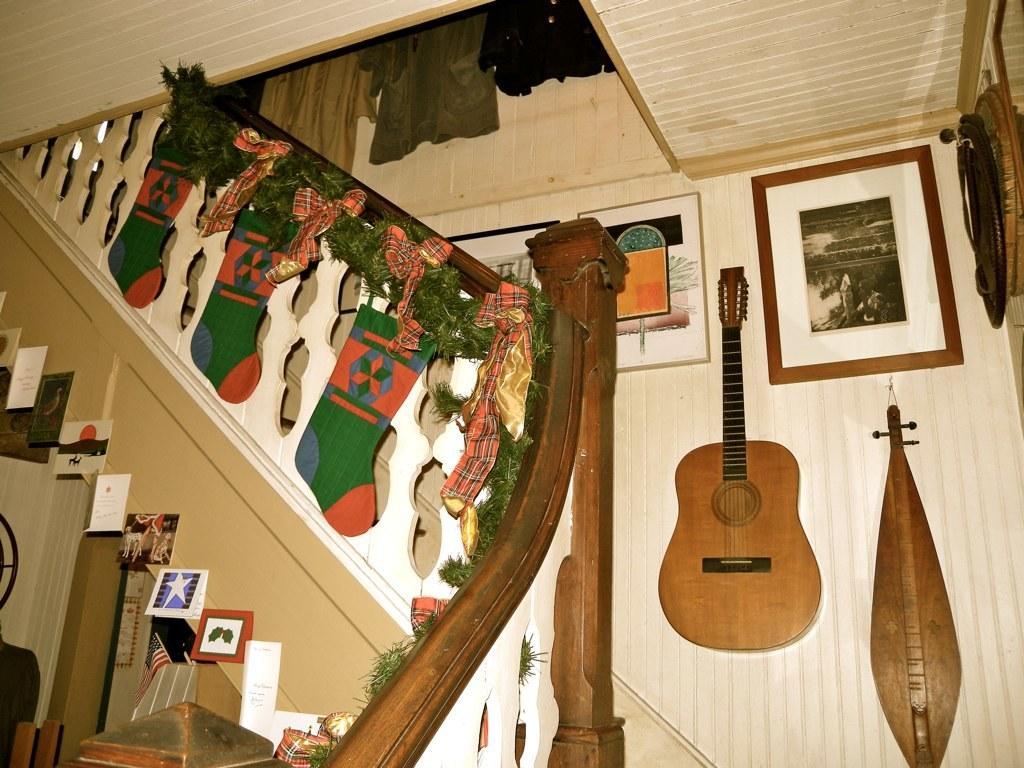Could you give a brief overview of what you see in this image? this pictures shows a guitar and a photo frames on the wall and we see some socks hanging to the stairs 